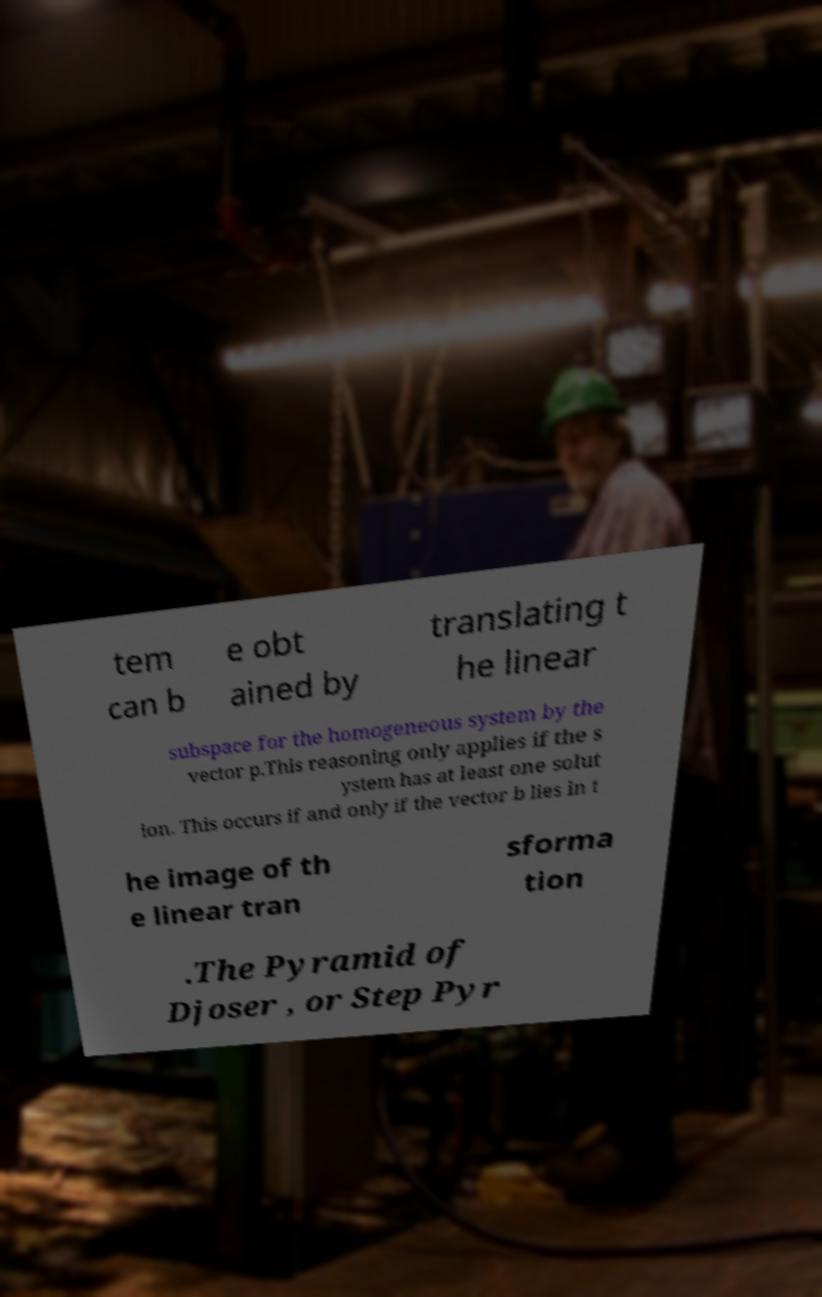I need the written content from this picture converted into text. Can you do that? tem can b e obt ained by translating t he linear subspace for the homogeneous system by the vector p.This reasoning only applies if the s ystem has at least one solut ion. This occurs if and only if the vector b lies in t he image of th e linear tran sforma tion .The Pyramid of Djoser , or Step Pyr 